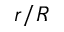Convert formula to latex. <formula><loc_0><loc_0><loc_500><loc_500>r / R</formula> 